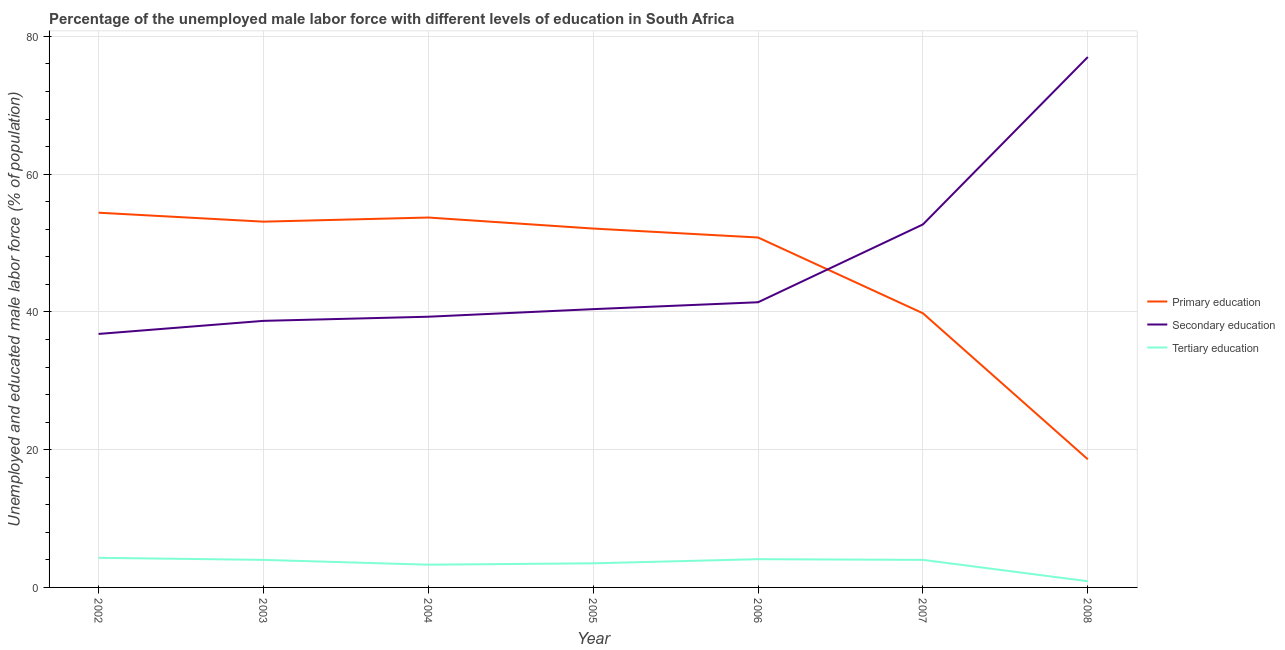How many different coloured lines are there?
Ensure brevity in your answer.  3. Does the line corresponding to percentage of male labor force who received tertiary education intersect with the line corresponding to percentage of male labor force who received secondary education?
Ensure brevity in your answer.  No. What is the percentage of male labor force who received secondary education in 2005?
Your answer should be compact. 40.4. Across all years, what is the maximum percentage of male labor force who received primary education?
Your answer should be compact. 54.4. Across all years, what is the minimum percentage of male labor force who received primary education?
Your answer should be very brief. 18.6. In which year was the percentage of male labor force who received secondary education minimum?
Your response must be concise. 2002. What is the total percentage of male labor force who received primary education in the graph?
Ensure brevity in your answer.  322.5. What is the difference between the percentage of male labor force who received primary education in 2003 and that in 2006?
Provide a short and direct response. 2.3. What is the difference between the percentage of male labor force who received tertiary education in 2007 and the percentage of male labor force who received primary education in 2006?
Keep it short and to the point. -46.8. What is the average percentage of male labor force who received primary education per year?
Keep it short and to the point. 46.07. In the year 2004, what is the difference between the percentage of male labor force who received tertiary education and percentage of male labor force who received secondary education?
Provide a succinct answer. -36. What is the ratio of the percentage of male labor force who received tertiary education in 2003 to that in 2008?
Your answer should be compact. 4.44. Is the percentage of male labor force who received secondary education in 2004 less than that in 2005?
Provide a succinct answer. Yes. What is the difference between the highest and the second highest percentage of male labor force who received secondary education?
Offer a very short reply. 24.3. What is the difference between the highest and the lowest percentage of male labor force who received secondary education?
Ensure brevity in your answer.  40.2. In how many years, is the percentage of male labor force who received secondary education greater than the average percentage of male labor force who received secondary education taken over all years?
Ensure brevity in your answer.  2. Is the percentage of male labor force who received tertiary education strictly greater than the percentage of male labor force who received secondary education over the years?
Make the answer very short. No. How many lines are there?
Provide a succinct answer. 3. How many years are there in the graph?
Ensure brevity in your answer.  7. What is the difference between two consecutive major ticks on the Y-axis?
Keep it short and to the point. 20. Are the values on the major ticks of Y-axis written in scientific E-notation?
Offer a very short reply. No. Does the graph contain any zero values?
Provide a short and direct response. No. How are the legend labels stacked?
Your answer should be compact. Vertical. What is the title of the graph?
Provide a succinct answer. Percentage of the unemployed male labor force with different levels of education in South Africa. Does "Coal sources" appear as one of the legend labels in the graph?
Your answer should be very brief. No. What is the label or title of the Y-axis?
Your response must be concise. Unemployed and educated male labor force (% of population). What is the Unemployed and educated male labor force (% of population) of Primary education in 2002?
Give a very brief answer. 54.4. What is the Unemployed and educated male labor force (% of population) of Secondary education in 2002?
Provide a short and direct response. 36.8. What is the Unemployed and educated male labor force (% of population) in Tertiary education in 2002?
Make the answer very short. 4.3. What is the Unemployed and educated male labor force (% of population) of Primary education in 2003?
Make the answer very short. 53.1. What is the Unemployed and educated male labor force (% of population) of Secondary education in 2003?
Provide a succinct answer. 38.7. What is the Unemployed and educated male labor force (% of population) in Tertiary education in 2003?
Provide a succinct answer. 4. What is the Unemployed and educated male labor force (% of population) of Primary education in 2004?
Give a very brief answer. 53.7. What is the Unemployed and educated male labor force (% of population) of Secondary education in 2004?
Provide a succinct answer. 39.3. What is the Unemployed and educated male labor force (% of population) of Tertiary education in 2004?
Give a very brief answer. 3.3. What is the Unemployed and educated male labor force (% of population) in Primary education in 2005?
Ensure brevity in your answer.  52.1. What is the Unemployed and educated male labor force (% of population) in Secondary education in 2005?
Offer a very short reply. 40.4. What is the Unemployed and educated male labor force (% of population) in Tertiary education in 2005?
Provide a short and direct response. 3.5. What is the Unemployed and educated male labor force (% of population) in Primary education in 2006?
Give a very brief answer. 50.8. What is the Unemployed and educated male labor force (% of population) of Secondary education in 2006?
Give a very brief answer. 41.4. What is the Unemployed and educated male labor force (% of population) in Tertiary education in 2006?
Offer a terse response. 4.1. What is the Unemployed and educated male labor force (% of population) in Primary education in 2007?
Your response must be concise. 39.8. What is the Unemployed and educated male labor force (% of population) in Secondary education in 2007?
Make the answer very short. 52.7. What is the Unemployed and educated male labor force (% of population) in Primary education in 2008?
Provide a succinct answer. 18.6. What is the Unemployed and educated male labor force (% of population) of Tertiary education in 2008?
Make the answer very short. 0.9. Across all years, what is the maximum Unemployed and educated male labor force (% of population) of Primary education?
Give a very brief answer. 54.4. Across all years, what is the maximum Unemployed and educated male labor force (% of population) in Tertiary education?
Keep it short and to the point. 4.3. Across all years, what is the minimum Unemployed and educated male labor force (% of population) of Primary education?
Your response must be concise. 18.6. Across all years, what is the minimum Unemployed and educated male labor force (% of population) in Secondary education?
Provide a short and direct response. 36.8. Across all years, what is the minimum Unemployed and educated male labor force (% of population) of Tertiary education?
Give a very brief answer. 0.9. What is the total Unemployed and educated male labor force (% of population) of Primary education in the graph?
Ensure brevity in your answer.  322.5. What is the total Unemployed and educated male labor force (% of population) of Secondary education in the graph?
Make the answer very short. 326.3. What is the total Unemployed and educated male labor force (% of population) of Tertiary education in the graph?
Provide a succinct answer. 24.1. What is the difference between the Unemployed and educated male labor force (% of population) in Primary education in 2002 and that in 2003?
Your answer should be very brief. 1.3. What is the difference between the Unemployed and educated male labor force (% of population) in Primary education in 2002 and that in 2004?
Your response must be concise. 0.7. What is the difference between the Unemployed and educated male labor force (% of population) in Secondary education in 2002 and that in 2004?
Your answer should be compact. -2.5. What is the difference between the Unemployed and educated male labor force (% of population) of Tertiary education in 2002 and that in 2004?
Keep it short and to the point. 1. What is the difference between the Unemployed and educated male labor force (% of population) in Secondary education in 2002 and that in 2005?
Make the answer very short. -3.6. What is the difference between the Unemployed and educated male labor force (% of population) of Tertiary education in 2002 and that in 2005?
Make the answer very short. 0.8. What is the difference between the Unemployed and educated male labor force (% of population) of Primary education in 2002 and that in 2006?
Provide a succinct answer. 3.6. What is the difference between the Unemployed and educated male labor force (% of population) of Secondary education in 2002 and that in 2007?
Keep it short and to the point. -15.9. What is the difference between the Unemployed and educated male labor force (% of population) in Primary education in 2002 and that in 2008?
Keep it short and to the point. 35.8. What is the difference between the Unemployed and educated male labor force (% of population) of Secondary education in 2002 and that in 2008?
Provide a short and direct response. -40.2. What is the difference between the Unemployed and educated male labor force (% of population) in Tertiary education in 2002 and that in 2008?
Keep it short and to the point. 3.4. What is the difference between the Unemployed and educated male labor force (% of population) in Secondary education in 2003 and that in 2004?
Provide a succinct answer. -0.6. What is the difference between the Unemployed and educated male labor force (% of population) of Secondary education in 2003 and that in 2005?
Keep it short and to the point. -1.7. What is the difference between the Unemployed and educated male labor force (% of population) of Tertiary education in 2003 and that in 2005?
Offer a terse response. 0.5. What is the difference between the Unemployed and educated male labor force (% of population) of Tertiary education in 2003 and that in 2006?
Provide a succinct answer. -0.1. What is the difference between the Unemployed and educated male labor force (% of population) of Secondary education in 2003 and that in 2007?
Give a very brief answer. -14. What is the difference between the Unemployed and educated male labor force (% of population) in Tertiary education in 2003 and that in 2007?
Provide a short and direct response. 0. What is the difference between the Unemployed and educated male labor force (% of population) in Primary education in 2003 and that in 2008?
Your response must be concise. 34.5. What is the difference between the Unemployed and educated male labor force (% of population) of Secondary education in 2003 and that in 2008?
Your answer should be very brief. -38.3. What is the difference between the Unemployed and educated male labor force (% of population) of Primary education in 2004 and that in 2005?
Your answer should be very brief. 1.6. What is the difference between the Unemployed and educated male labor force (% of population) in Secondary education in 2004 and that in 2005?
Provide a succinct answer. -1.1. What is the difference between the Unemployed and educated male labor force (% of population) of Tertiary education in 2004 and that in 2005?
Your answer should be compact. -0.2. What is the difference between the Unemployed and educated male labor force (% of population) of Secondary education in 2004 and that in 2006?
Ensure brevity in your answer.  -2.1. What is the difference between the Unemployed and educated male labor force (% of population) in Primary education in 2004 and that in 2007?
Your answer should be very brief. 13.9. What is the difference between the Unemployed and educated male labor force (% of population) in Secondary education in 2004 and that in 2007?
Your answer should be very brief. -13.4. What is the difference between the Unemployed and educated male labor force (% of population) of Primary education in 2004 and that in 2008?
Make the answer very short. 35.1. What is the difference between the Unemployed and educated male labor force (% of population) of Secondary education in 2004 and that in 2008?
Your answer should be very brief. -37.7. What is the difference between the Unemployed and educated male labor force (% of population) of Primary education in 2005 and that in 2006?
Offer a terse response. 1.3. What is the difference between the Unemployed and educated male labor force (% of population) in Secondary education in 2005 and that in 2006?
Offer a terse response. -1. What is the difference between the Unemployed and educated male labor force (% of population) of Secondary education in 2005 and that in 2007?
Your response must be concise. -12.3. What is the difference between the Unemployed and educated male labor force (% of population) of Tertiary education in 2005 and that in 2007?
Offer a terse response. -0.5. What is the difference between the Unemployed and educated male labor force (% of population) of Primary education in 2005 and that in 2008?
Your answer should be compact. 33.5. What is the difference between the Unemployed and educated male labor force (% of population) in Secondary education in 2005 and that in 2008?
Ensure brevity in your answer.  -36.6. What is the difference between the Unemployed and educated male labor force (% of population) of Tertiary education in 2005 and that in 2008?
Offer a terse response. 2.6. What is the difference between the Unemployed and educated male labor force (% of population) of Primary education in 2006 and that in 2007?
Give a very brief answer. 11. What is the difference between the Unemployed and educated male labor force (% of population) of Primary education in 2006 and that in 2008?
Offer a terse response. 32.2. What is the difference between the Unemployed and educated male labor force (% of population) in Secondary education in 2006 and that in 2008?
Your answer should be very brief. -35.6. What is the difference between the Unemployed and educated male labor force (% of population) in Primary education in 2007 and that in 2008?
Your answer should be compact. 21.2. What is the difference between the Unemployed and educated male labor force (% of population) of Secondary education in 2007 and that in 2008?
Give a very brief answer. -24.3. What is the difference between the Unemployed and educated male labor force (% of population) in Tertiary education in 2007 and that in 2008?
Your answer should be very brief. 3.1. What is the difference between the Unemployed and educated male labor force (% of population) in Primary education in 2002 and the Unemployed and educated male labor force (% of population) in Secondary education in 2003?
Offer a terse response. 15.7. What is the difference between the Unemployed and educated male labor force (% of population) of Primary education in 2002 and the Unemployed and educated male labor force (% of population) of Tertiary education in 2003?
Keep it short and to the point. 50.4. What is the difference between the Unemployed and educated male labor force (% of population) of Secondary education in 2002 and the Unemployed and educated male labor force (% of population) of Tertiary education in 2003?
Offer a very short reply. 32.8. What is the difference between the Unemployed and educated male labor force (% of population) in Primary education in 2002 and the Unemployed and educated male labor force (% of population) in Secondary education in 2004?
Make the answer very short. 15.1. What is the difference between the Unemployed and educated male labor force (% of population) of Primary education in 2002 and the Unemployed and educated male labor force (% of population) of Tertiary education in 2004?
Your answer should be compact. 51.1. What is the difference between the Unemployed and educated male labor force (% of population) of Secondary education in 2002 and the Unemployed and educated male labor force (% of population) of Tertiary education in 2004?
Your answer should be compact. 33.5. What is the difference between the Unemployed and educated male labor force (% of population) in Primary education in 2002 and the Unemployed and educated male labor force (% of population) in Tertiary education in 2005?
Your response must be concise. 50.9. What is the difference between the Unemployed and educated male labor force (% of population) in Secondary education in 2002 and the Unemployed and educated male labor force (% of population) in Tertiary education in 2005?
Your answer should be compact. 33.3. What is the difference between the Unemployed and educated male labor force (% of population) in Primary education in 2002 and the Unemployed and educated male labor force (% of population) in Secondary education in 2006?
Provide a short and direct response. 13. What is the difference between the Unemployed and educated male labor force (% of population) in Primary education in 2002 and the Unemployed and educated male labor force (% of population) in Tertiary education in 2006?
Offer a very short reply. 50.3. What is the difference between the Unemployed and educated male labor force (% of population) of Secondary education in 2002 and the Unemployed and educated male labor force (% of population) of Tertiary education in 2006?
Your answer should be compact. 32.7. What is the difference between the Unemployed and educated male labor force (% of population) of Primary education in 2002 and the Unemployed and educated male labor force (% of population) of Tertiary education in 2007?
Provide a short and direct response. 50.4. What is the difference between the Unemployed and educated male labor force (% of population) in Secondary education in 2002 and the Unemployed and educated male labor force (% of population) in Tertiary education in 2007?
Your answer should be very brief. 32.8. What is the difference between the Unemployed and educated male labor force (% of population) in Primary education in 2002 and the Unemployed and educated male labor force (% of population) in Secondary education in 2008?
Keep it short and to the point. -22.6. What is the difference between the Unemployed and educated male labor force (% of population) in Primary education in 2002 and the Unemployed and educated male labor force (% of population) in Tertiary education in 2008?
Make the answer very short. 53.5. What is the difference between the Unemployed and educated male labor force (% of population) in Secondary education in 2002 and the Unemployed and educated male labor force (% of population) in Tertiary education in 2008?
Ensure brevity in your answer.  35.9. What is the difference between the Unemployed and educated male labor force (% of population) in Primary education in 2003 and the Unemployed and educated male labor force (% of population) in Tertiary education in 2004?
Provide a succinct answer. 49.8. What is the difference between the Unemployed and educated male labor force (% of population) of Secondary education in 2003 and the Unemployed and educated male labor force (% of population) of Tertiary education in 2004?
Your response must be concise. 35.4. What is the difference between the Unemployed and educated male labor force (% of population) of Primary education in 2003 and the Unemployed and educated male labor force (% of population) of Secondary education in 2005?
Make the answer very short. 12.7. What is the difference between the Unemployed and educated male labor force (% of population) of Primary education in 2003 and the Unemployed and educated male labor force (% of population) of Tertiary education in 2005?
Offer a terse response. 49.6. What is the difference between the Unemployed and educated male labor force (% of population) of Secondary education in 2003 and the Unemployed and educated male labor force (% of population) of Tertiary education in 2005?
Your response must be concise. 35.2. What is the difference between the Unemployed and educated male labor force (% of population) of Primary education in 2003 and the Unemployed and educated male labor force (% of population) of Secondary education in 2006?
Ensure brevity in your answer.  11.7. What is the difference between the Unemployed and educated male labor force (% of population) of Primary education in 2003 and the Unemployed and educated male labor force (% of population) of Tertiary education in 2006?
Your answer should be very brief. 49. What is the difference between the Unemployed and educated male labor force (% of population) of Secondary education in 2003 and the Unemployed and educated male labor force (% of population) of Tertiary education in 2006?
Offer a terse response. 34.6. What is the difference between the Unemployed and educated male labor force (% of population) of Primary education in 2003 and the Unemployed and educated male labor force (% of population) of Secondary education in 2007?
Your response must be concise. 0.4. What is the difference between the Unemployed and educated male labor force (% of population) of Primary education in 2003 and the Unemployed and educated male labor force (% of population) of Tertiary education in 2007?
Ensure brevity in your answer.  49.1. What is the difference between the Unemployed and educated male labor force (% of population) of Secondary education in 2003 and the Unemployed and educated male labor force (% of population) of Tertiary education in 2007?
Your answer should be very brief. 34.7. What is the difference between the Unemployed and educated male labor force (% of population) of Primary education in 2003 and the Unemployed and educated male labor force (% of population) of Secondary education in 2008?
Your answer should be very brief. -23.9. What is the difference between the Unemployed and educated male labor force (% of population) in Primary education in 2003 and the Unemployed and educated male labor force (% of population) in Tertiary education in 2008?
Your response must be concise. 52.2. What is the difference between the Unemployed and educated male labor force (% of population) in Secondary education in 2003 and the Unemployed and educated male labor force (% of population) in Tertiary education in 2008?
Your answer should be very brief. 37.8. What is the difference between the Unemployed and educated male labor force (% of population) of Primary education in 2004 and the Unemployed and educated male labor force (% of population) of Secondary education in 2005?
Provide a short and direct response. 13.3. What is the difference between the Unemployed and educated male labor force (% of population) in Primary education in 2004 and the Unemployed and educated male labor force (% of population) in Tertiary education in 2005?
Your answer should be compact. 50.2. What is the difference between the Unemployed and educated male labor force (% of population) in Secondary education in 2004 and the Unemployed and educated male labor force (% of population) in Tertiary education in 2005?
Provide a short and direct response. 35.8. What is the difference between the Unemployed and educated male labor force (% of population) of Primary education in 2004 and the Unemployed and educated male labor force (% of population) of Tertiary education in 2006?
Your answer should be compact. 49.6. What is the difference between the Unemployed and educated male labor force (% of population) in Secondary education in 2004 and the Unemployed and educated male labor force (% of population) in Tertiary education in 2006?
Keep it short and to the point. 35.2. What is the difference between the Unemployed and educated male labor force (% of population) in Primary education in 2004 and the Unemployed and educated male labor force (% of population) in Tertiary education in 2007?
Offer a very short reply. 49.7. What is the difference between the Unemployed and educated male labor force (% of population) of Secondary education in 2004 and the Unemployed and educated male labor force (% of population) of Tertiary education in 2007?
Keep it short and to the point. 35.3. What is the difference between the Unemployed and educated male labor force (% of population) in Primary education in 2004 and the Unemployed and educated male labor force (% of population) in Secondary education in 2008?
Make the answer very short. -23.3. What is the difference between the Unemployed and educated male labor force (% of population) in Primary education in 2004 and the Unemployed and educated male labor force (% of population) in Tertiary education in 2008?
Offer a terse response. 52.8. What is the difference between the Unemployed and educated male labor force (% of population) in Secondary education in 2004 and the Unemployed and educated male labor force (% of population) in Tertiary education in 2008?
Make the answer very short. 38.4. What is the difference between the Unemployed and educated male labor force (% of population) in Primary education in 2005 and the Unemployed and educated male labor force (% of population) in Secondary education in 2006?
Provide a short and direct response. 10.7. What is the difference between the Unemployed and educated male labor force (% of population) in Secondary education in 2005 and the Unemployed and educated male labor force (% of population) in Tertiary education in 2006?
Give a very brief answer. 36.3. What is the difference between the Unemployed and educated male labor force (% of population) of Primary education in 2005 and the Unemployed and educated male labor force (% of population) of Secondary education in 2007?
Offer a terse response. -0.6. What is the difference between the Unemployed and educated male labor force (% of population) in Primary education in 2005 and the Unemployed and educated male labor force (% of population) in Tertiary education in 2007?
Ensure brevity in your answer.  48.1. What is the difference between the Unemployed and educated male labor force (% of population) in Secondary education in 2005 and the Unemployed and educated male labor force (% of population) in Tertiary education in 2007?
Offer a terse response. 36.4. What is the difference between the Unemployed and educated male labor force (% of population) in Primary education in 2005 and the Unemployed and educated male labor force (% of population) in Secondary education in 2008?
Offer a terse response. -24.9. What is the difference between the Unemployed and educated male labor force (% of population) in Primary education in 2005 and the Unemployed and educated male labor force (% of population) in Tertiary education in 2008?
Make the answer very short. 51.2. What is the difference between the Unemployed and educated male labor force (% of population) in Secondary education in 2005 and the Unemployed and educated male labor force (% of population) in Tertiary education in 2008?
Offer a terse response. 39.5. What is the difference between the Unemployed and educated male labor force (% of population) of Primary education in 2006 and the Unemployed and educated male labor force (% of population) of Tertiary education in 2007?
Make the answer very short. 46.8. What is the difference between the Unemployed and educated male labor force (% of population) in Secondary education in 2006 and the Unemployed and educated male labor force (% of population) in Tertiary education in 2007?
Provide a short and direct response. 37.4. What is the difference between the Unemployed and educated male labor force (% of population) of Primary education in 2006 and the Unemployed and educated male labor force (% of population) of Secondary education in 2008?
Make the answer very short. -26.2. What is the difference between the Unemployed and educated male labor force (% of population) in Primary education in 2006 and the Unemployed and educated male labor force (% of population) in Tertiary education in 2008?
Provide a succinct answer. 49.9. What is the difference between the Unemployed and educated male labor force (% of population) in Secondary education in 2006 and the Unemployed and educated male labor force (% of population) in Tertiary education in 2008?
Your answer should be very brief. 40.5. What is the difference between the Unemployed and educated male labor force (% of population) in Primary education in 2007 and the Unemployed and educated male labor force (% of population) in Secondary education in 2008?
Provide a succinct answer. -37.2. What is the difference between the Unemployed and educated male labor force (% of population) in Primary education in 2007 and the Unemployed and educated male labor force (% of population) in Tertiary education in 2008?
Provide a succinct answer. 38.9. What is the difference between the Unemployed and educated male labor force (% of population) in Secondary education in 2007 and the Unemployed and educated male labor force (% of population) in Tertiary education in 2008?
Your answer should be very brief. 51.8. What is the average Unemployed and educated male labor force (% of population) in Primary education per year?
Provide a short and direct response. 46.07. What is the average Unemployed and educated male labor force (% of population) of Secondary education per year?
Provide a succinct answer. 46.61. What is the average Unemployed and educated male labor force (% of population) of Tertiary education per year?
Offer a terse response. 3.44. In the year 2002, what is the difference between the Unemployed and educated male labor force (% of population) in Primary education and Unemployed and educated male labor force (% of population) in Tertiary education?
Your answer should be compact. 50.1. In the year 2002, what is the difference between the Unemployed and educated male labor force (% of population) of Secondary education and Unemployed and educated male labor force (% of population) of Tertiary education?
Provide a succinct answer. 32.5. In the year 2003, what is the difference between the Unemployed and educated male labor force (% of population) in Primary education and Unemployed and educated male labor force (% of population) in Tertiary education?
Give a very brief answer. 49.1. In the year 2003, what is the difference between the Unemployed and educated male labor force (% of population) in Secondary education and Unemployed and educated male labor force (% of population) in Tertiary education?
Keep it short and to the point. 34.7. In the year 2004, what is the difference between the Unemployed and educated male labor force (% of population) in Primary education and Unemployed and educated male labor force (% of population) in Tertiary education?
Keep it short and to the point. 50.4. In the year 2005, what is the difference between the Unemployed and educated male labor force (% of population) in Primary education and Unemployed and educated male labor force (% of population) in Tertiary education?
Your answer should be compact. 48.6. In the year 2005, what is the difference between the Unemployed and educated male labor force (% of population) of Secondary education and Unemployed and educated male labor force (% of population) of Tertiary education?
Provide a short and direct response. 36.9. In the year 2006, what is the difference between the Unemployed and educated male labor force (% of population) in Primary education and Unemployed and educated male labor force (% of population) in Secondary education?
Your answer should be compact. 9.4. In the year 2006, what is the difference between the Unemployed and educated male labor force (% of population) in Primary education and Unemployed and educated male labor force (% of population) in Tertiary education?
Ensure brevity in your answer.  46.7. In the year 2006, what is the difference between the Unemployed and educated male labor force (% of population) in Secondary education and Unemployed and educated male labor force (% of population) in Tertiary education?
Your answer should be very brief. 37.3. In the year 2007, what is the difference between the Unemployed and educated male labor force (% of population) of Primary education and Unemployed and educated male labor force (% of population) of Secondary education?
Offer a terse response. -12.9. In the year 2007, what is the difference between the Unemployed and educated male labor force (% of population) of Primary education and Unemployed and educated male labor force (% of population) of Tertiary education?
Offer a very short reply. 35.8. In the year 2007, what is the difference between the Unemployed and educated male labor force (% of population) of Secondary education and Unemployed and educated male labor force (% of population) of Tertiary education?
Your response must be concise. 48.7. In the year 2008, what is the difference between the Unemployed and educated male labor force (% of population) in Primary education and Unemployed and educated male labor force (% of population) in Secondary education?
Offer a terse response. -58.4. In the year 2008, what is the difference between the Unemployed and educated male labor force (% of population) in Secondary education and Unemployed and educated male labor force (% of population) in Tertiary education?
Offer a very short reply. 76.1. What is the ratio of the Unemployed and educated male labor force (% of population) of Primary education in 2002 to that in 2003?
Offer a very short reply. 1.02. What is the ratio of the Unemployed and educated male labor force (% of population) of Secondary education in 2002 to that in 2003?
Your response must be concise. 0.95. What is the ratio of the Unemployed and educated male labor force (% of population) in Tertiary education in 2002 to that in 2003?
Keep it short and to the point. 1.07. What is the ratio of the Unemployed and educated male labor force (% of population) of Secondary education in 2002 to that in 2004?
Give a very brief answer. 0.94. What is the ratio of the Unemployed and educated male labor force (% of population) of Tertiary education in 2002 to that in 2004?
Your answer should be compact. 1.3. What is the ratio of the Unemployed and educated male labor force (% of population) of Primary education in 2002 to that in 2005?
Provide a succinct answer. 1.04. What is the ratio of the Unemployed and educated male labor force (% of population) in Secondary education in 2002 to that in 2005?
Provide a succinct answer. 0.91. What is the ratio of the Unemployed and educated male labor force (% of population) of Tertiary education in 2002 to that in 2005?
Keep it short and to the point. 1.23. What is the ratio of the Unemployed and educated male labor force (% of population) in Primary education in 2002 to that in 2006?
Give a very brief answer. 1.07. What is the ratio of the Unemployed and educated male labor force (% of population) of Secondary education in 2002 to that in 2006?
Make the answer very short. 0.89. What is the ratio of the Unemployed and educated male labor force (% of population) of Tertiary education in 2002 to that in 2006?
Provide a short and direct response. 1.05. What is the ratio of the Unemployed and educated male labor force (% of population) of Primary education in 2002 to that in 2007?
Your response must be concise. 1.37. What is the ratio of the Unemployed and educated male labor force (% of population) in Secondary education in 2002 to that in 2007?
Keep it short and to the point. 0.7. What is the ratio of the Unemployed and educated male labor force (% of population) of Tertiary education in 2002 to that in 2007?
Keep it short and to the point. 1.07. What is the ratio of the Unemployed and educated male labor force (% of population) in Primary education in 2002 to that in 2008?
Make the answer very short. 2.92. What is the ratio of the Unemployed and educated male labor force (% of population) of Secondary education in 2002 to that in 2008?
Keep it short and to the point. 0.48. What is the ratio of the Unemployed and educated male labor force (% of population) in Tertiary education in 2002 to that in 2008?
Offer a very short reply. 4.78. What is the ratio of the Unemployed and educated male labor force (% of population) in Secondary education in 2003 to that in 2004?
Make the answer very short. 0.98. What is the ratio of the Unemployed and educated male labor force (% of population) in Tertiary education in 2003 to that in 2004?
Give a very brief answer. 1.21. What is the ratio of the Unemployed and educated male labor force (% of population) in Primary education in 2003 to that in 2005?
Your response must be concise. 1.02. What is the ratio of the Unemployed and educated male labor force (% of population) in Secondary education in 2003 to that in 2005?
Your answer should be very brief. 0.96. What is the ratio of the Unemployed and educated male labor force (% of population) of Tertiary education in 2003 to that in 2005?
Keep it short and to the point. 1.14. What is the ratio of the Unemployed and educated male labor force (% of population) of Primary education in 2003 to that in 2006?
Provide a succinct answer. 1.05. What is the ratio of the Unemployed and educated male labor force (% of population) of Secondary education in 2003 to that in 2006?
Provide a succinct answer. 0.93. What is the ratio of the Unemployed and educated male labor force (% of population) in Tertiary education in 2003 to that in 2006?
Provide a short and direct response. 0.98. What is the ratio of the Unemployed and educated male labor force (% of population) in Primary education in 2003 to that in 2007?
Provide a short and direct response. 1.33. What is the ratio of the Unemployed and educated male labor force (% of population) of Secondary education in 2003 to that in 2007?
Your response must be concise. 0.73. What is the ratio of the Unemployed and educated male labor force (% of population) of Tertiary education in 2003 to that in 2007?
Ensure brevity in your answer.  1. What is the ratio of the Unemployed and educated male labor force (% of population) in Primary education in 2003 to that in 2008?
Offer a very short reply. 2.85. What is the ratio of the Unemployed and educated male labor force (% of population) in Secondary education in 2003 to that in 2008?
Ensure brevity in your answer.  0.5. What is the ratio of the Unemployed and educated male labor force (% of population) in Tertiary education in 2003 to that in 2008?
Give a very brief answer. 4.44. What is the ratio of the Unemployed and educated male labor force (% of population) in Primary education in 2004 to that in 2005?
Your answer should be compact. 1.03. What is the ratio of the Unemployed and educated male labor force (% of population) in Secondary education in 2004 to that in 2005?
Keep it short and to the point. 0.97. What is the ratio of the Unemployed and educated male labor force (% of population) in Tertiary education in 2004 to that in 2005?
Your response must be concise. 0.94. What is the ratio of the Unemployed and educated male labor force (% of population) of Primary education in 2004 to that in 2006?
Your answer should be compact. 1.06. What is the ratio of the Unemployed and educated male labor force (% of population) of Secondary education in 2004 to that in 2006?
Your answer should be compact. 0.95. What is the ratio of the Unemployed and educated male labor force (% of population) in Tertiary education in 2004 to that in 2006?
Your answer should be very brief. 0.8. What is the ratio of the Unemployed and educated male labor force (% of population) in Primary education in 2004 to that in 2007?
Provide a short and direct response. 1.35. What is the ratio of the Unemployed and educated male labor force (% of population) in Secondary education in 2004 to that in 2007?
Give a very brief answer. 0.75. What is the ratio of the Unemployed and educated male labor force (% of population) in Tertiary education in 2004 to that in 2007?
Your response must be concise. 0.82. What is the ratio of the Unemployed and educated male labor force (% of population) of Primary education in 2004 to that in 2008?
Give a very brief answer. 2.89. What is the ratio of the Unemployed and educated male labor force (% of population) in Secondary education in 2004 to that in 2008?
Provide a succinct answer. 0.51. What is the ratio of the Unemployed and educated male labor force (% of population) in Tertiary education in 2004 to that in 2008?
Give a very brief answer. 3.67. What is the ratio of the Unemployed and educated male labor force (% of population) in Primary education in 2005 to that in 2006?
Provide a succinct answer. 1.03. What is the ratio of the Unemployed and educated male labor force (% of population) in Secondary education in 2005 to that in 2006?
Your response must be concise. 0.98. What is the ratio of the Unemployed and educated male labor force (% of population) in Tertiary education in 2005 to that in 2006?
Offer a very short reply. 0.85. What is the ratio of the Unemployed and educated male labor force (% of population) in Primary education in 2005 to that in 2007?
Provide a short and direct response. 1.31. What is the ratio of the Unemployed and educated male labor force (% of population) in Secondary education in 2005 to that in 2007?
Your answer should be compact. 0.77. What is the ratio of the Unemployed and educated male labor force (% of population) in Tertiary education in 2005 to that in 2007?
Give a very brief answer. 0.88. What is the ratio of the Unemployed and educated male labor force (% of population) of Primary education in 2005 to that in 2008?
Provide a short and direct response. 2.8. What is the ratio of the Unemployed and educated male labor force (% of population) in Secondary education in 2005 to that in 2008?
Provide a short and direct response. 0.52. What is the ratio of the Unemployed and educated male labor force (% of population) of Tertiary education in 2005 to that in 2008?
Offer a very short reply. 3.89. What is the ratio of the Unemployed and educated male labor force (% of population) of Primary education in 2006 to that in 2007?
Give a very brief answer. 1.28. What is the ratio of the Unemployed and educated male labor force (% of population) of Secondary education in 2006 to that in 2007?
Make the answer very short. 0.79. What is the ratio of the Unemployed and educated male labor force (% of population) in Tertiary education in 2006 to that in 2007?
Provide a succinct answer. 1.02. What is the ratio of the Unemployed and educated male labor force (% of population) of Primary education in 2006 to that in 2008?
Offer a very short reply. 2.73. What is the ratio of the Unemployed and educated male labor force (% of population) of Secondary education in 2006 to that in 2008?
Provide a short and direct response. 0.54. What is the ratio of the Unemployed and educated male labor force (% of population) in Tertiary education in 2006 to that in 2008?
Ensure brevity in your answer.  4.56. What is the ratio of the Unemployed and educated male labor force (% of population) in Primary education in 2007 to that in 2008?
Provide a succinct answer. 2.14. What is the ratio of the Unemployed and educated male labor force (% of population) in Secondary education in 2007 to that in 2008?
Provide a short and direct response. 0.68. What is the ratio of the Unemployed and educated male labor force (% of population) in Tertiary education in 2007 to that in 2008?
Provide a succinct answer. 4.44. What is the difference between the highest and the second highest Unemployed and educated male labor force (% of population) of Secondary education?
Your response must be concise. 24.3. What is the difference between the highest and the lowest Unemployed and educated male labor force (% of population) of Primary education?
Your answer should be very brief. 35.8. What is the difference between the highest and the lowest Unemployed and educated male labor force (% of population) of Secondary education?
Keep it short and to the point. 40.2. What is the difference between the highest and the lowest Unemployed and educated male labor force (% of population) in Tertiary education?
Ensure brevity in your answer.  3.4. 